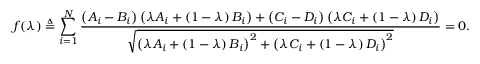<formula> <loc_0><loc_0><loc_500><loc_500>f ( \lambda ) \triangle q \sum _ { i = 1 } ^ { N } \frac { \left ( A _ { i } - B _ { i } \right ) \left ( \lambda A _ { i } + \left ( 1 - \lambda \right ) B _ { i } \right ) + \left ( C _ { i } - D _ { i } \right ) \left ( \lambda C _ { i } + \left ( 1 - \lambda \right ) D _ { i } \right ) } { \sqrt { \left ( \lambda A _ { i } + \left ( 1 - \lambda \right ) B _ { i } \right ) ^ { 2 } + \left ( \lambda C _ { i } + \left ( 1 - \lambda \right ) D _ { i } \right ) ^ { 2 } } } = 0 .</formula> 